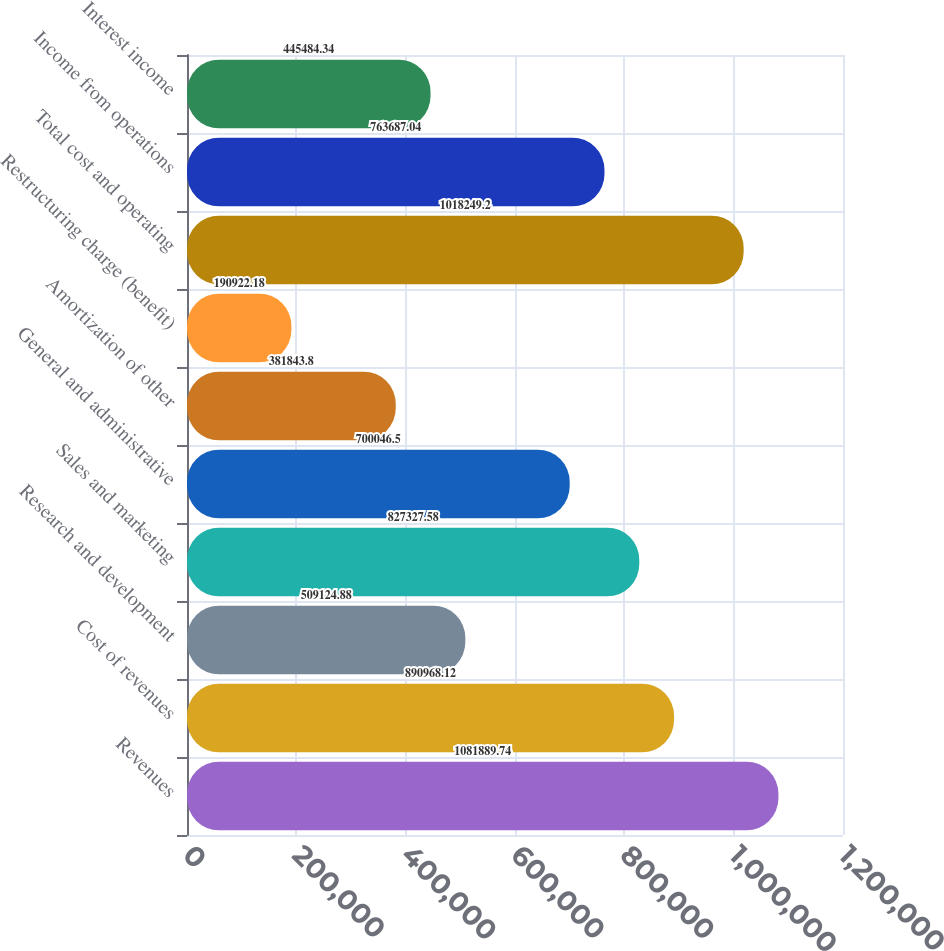<chart> <loc_0><loc_0><loc_500><loc_500><bar_chart><fcel>Revenues<fcel>Cost of revenues<fcel>Research and development<fcel>Sales and marketing<fcel>General and administrative<fcel>Amortization of other<fcel>Restructuring charge (benefit)<fcel>Total cost and operating<fcel>Income from operations<fcel>Interest income<nl><fcel>1.08189e+06<fcel>890968<fcel>509125<fcel>827328<fcel>700046<fcel>381844<fcel>190922<fcel>1.01825e+06<fcel>763687<fcel>445484<nl></chart> 